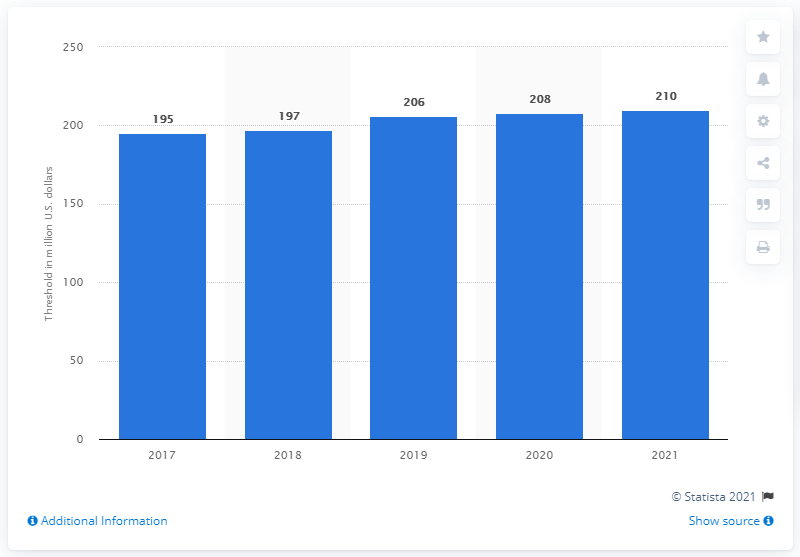Mention a couple of crucial points in this snapshot. In 2020, the payroll threshold for Major League Baseball clubs was 210 million dollars. 